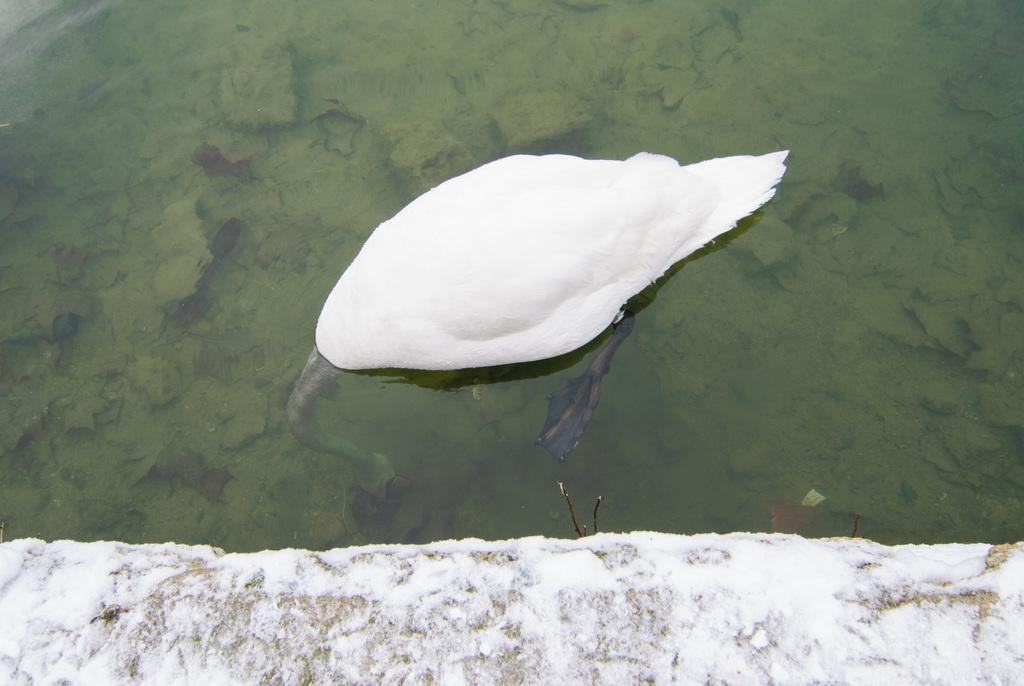What animal is present in the image? There is a swan in the image. Where is the swan located? The swan is in the water. What type of weather condition is depicted in the image? There is snow visible in the image. What season is it in the image? The image does not provide any specific information about the season, but the presence of snow suggests it could be winter. What type of station is present in the image? There is no station present in the image; it features a swan in the water with snow visible. 